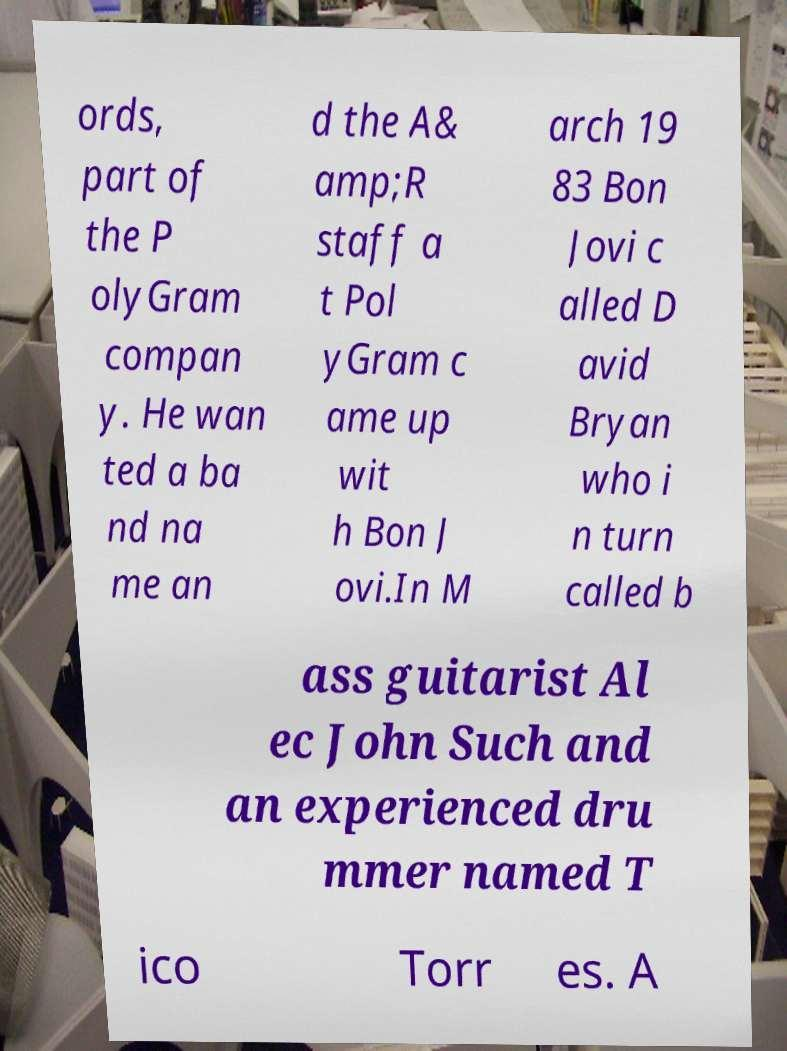Please identify and transcribe the text found in this image. ords, part of the P olyGram compan y. He wan ted a ba nd na me an d the A& amp;R staff a t Pol yGram c ame up wit h Bon J ovi.In M arch 19 83 Bon Jovi c alled D avid Bryan who i n turn called b ass guitarist Al ec John Such and an experienced dru mmer named T ico Torr es. A 